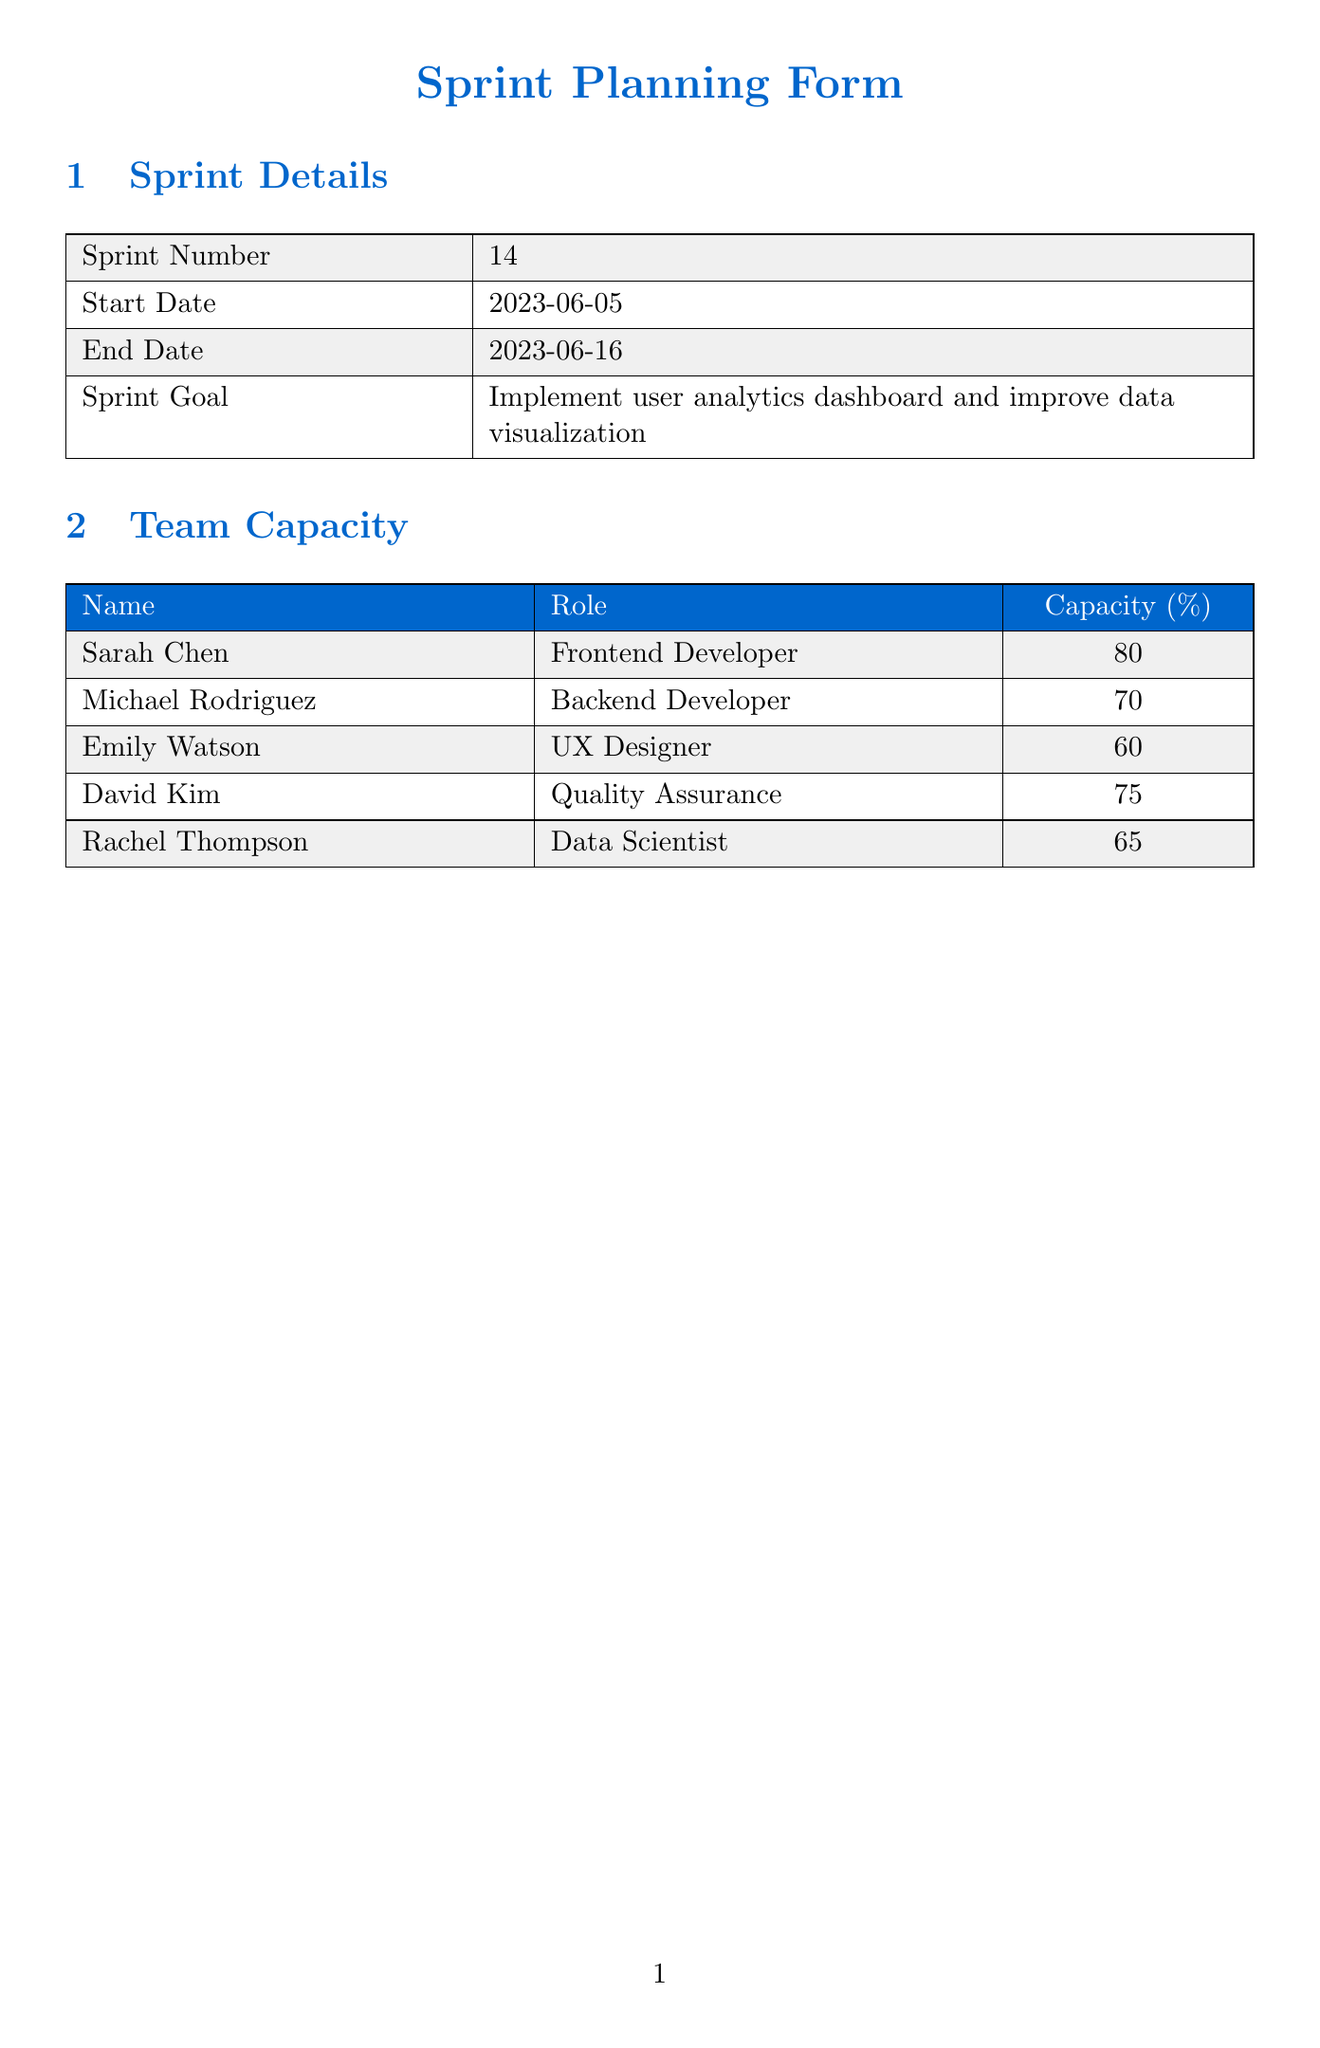what is the sprint number? The sprint number is mentioned in the sprint details section of the document.
Answer: 14 who is assigned to implement user session tracking? The assignee for implementing user session tracking is specified under the user stories section.
Answer: Michael Rodriguez what is the capacity of the Frontend Developer? The capacity of team members is detailed in the team capacity section.
Answer: 80 how many story points are allocated to creating interactive data visualization components? The number of story points for each user story is listed in the user stories section.
Answer: 21 what is the impact of the risk related to data privacy compliance? The risk assessment section outlines the impact of each identified risk.
Answer: High which user story depends on US-144? This information can be found in the dependency matrix section.
Answer: US-145 what is the start date of the sprint? The start date is provided in the sprint details section.
Answer: 2023-06-05 name one area for improvement identified in the retrospective. Areas for improvement are listed in the sprint retrospective section.
Answer: Better estimation of story points how many tasks are assigned to Rachel Thompson? The number of user stories assigned to each team member can be counted from the user stories section.
Answer: 1 